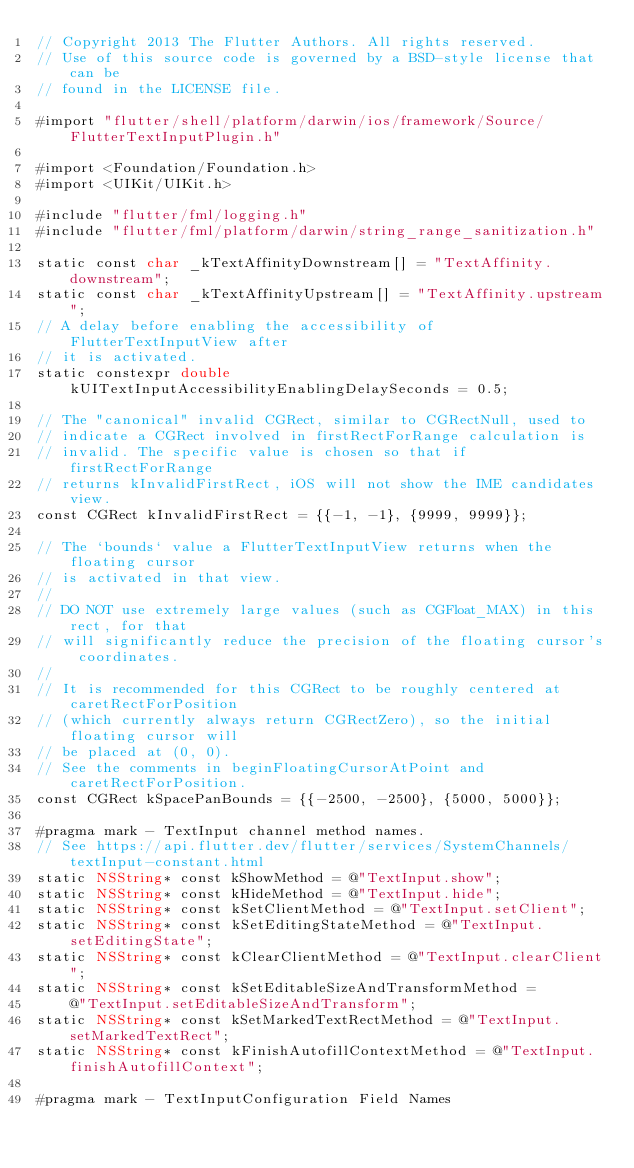Convert code to text. <code><loc_0><loc_0><loc_500><loc_500><_ObjectiveC_>// Copyright 2013 The Flutter Authors. All rights reserved.
// Use of this source code is governed by a BSD-style license that can be
// found in the LICENSE file.

#import "flutter/shell/platform/darwin/ios/framework/Source/FlutterTextInputPlugin.h"

#import <Foundation/Foundation.h>
#import <UIKit/UIKit.h>

#include "flutter/fml/logging.h"
#include "flutter/fml/platform/darwin/string_range_sanitization.h"

static const char _kTextAffinityDownstream[] = "TextAffinity.downstream";
static const char _kTextAffinityUpstream[] = "TextAffinity.upstream";
// A delay before enabling the accessibility of FlutterTextInputView after
// it is activated.
static constexpr double kUITextInputAccessibilityEnablingDelaySeconds = 0.5;

// The "canonical" invalid CGRect, similar to CGRectNull, used to
// indicate a CGRect involved in firstRectForRange calculation is
// invalid. The specific value is chosen so that if firstRectForRange
// returns kInvalidFirstRect, iOS will not show the IME candidates view.
const CGRect kInvalidFirstRect = {{-1, -1}, {9999, 9999}};

// The `bounds` value a FlutterTextInputView returns when the floating cursor
// is activated in that view.
//
// DO NOT use extremely large values (such as CGFloat_MAX) in this rect, for that
// will significantly reduce the precision of the floating cursor's coordinates.
//
// It is recommended for this CGRect to be roughly centered at caretRectForPosition
// (which currently always return CGRectZero), so the initial floating cursor will
// be placed at (0, 0).
// See the comments in beginFloatingCursorAtPoint and caretRectForPosition.
const CGRect kSpacePanBounds = {{-2500, -2500}, {5000, 5000}};

#pragma mark - TextInput channel method names.
// See https://api.flutter.dev/flutter/services/SystemChannels/textInput-constant.html
static NSString* const kShowMethod = @"TextInput.show";
static NSString* const kHideMethod = @"TextInput.hide";
static NSString* const kSetClientMethod = @"TextInput.setClient";
static NSString* const kSetEditingStateMethod = @"TextInput.setEditingState";
static NSString* const kClearClientMethod = @"TextInput.clearClient";
static NSString* const kSetEditableSizeAndTransformMethod =
    @"TextInput.setEditableSizeAndTransform";
static NSString* const kSetMarkedTextRectMethod = @"TextInput.setMarkedTextRect";
static NSString* const kFinishAutofillContextMethod = @"TextInput.finishAutofillContext";

#pragma mark - TextInputConfiguration Field Names</code> 